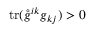<formula> <loc_0><loc_0><loc_500><loc_500>t r ( \mathring { g } ^ { i k } g _ { k j } ) > 0</formula> 